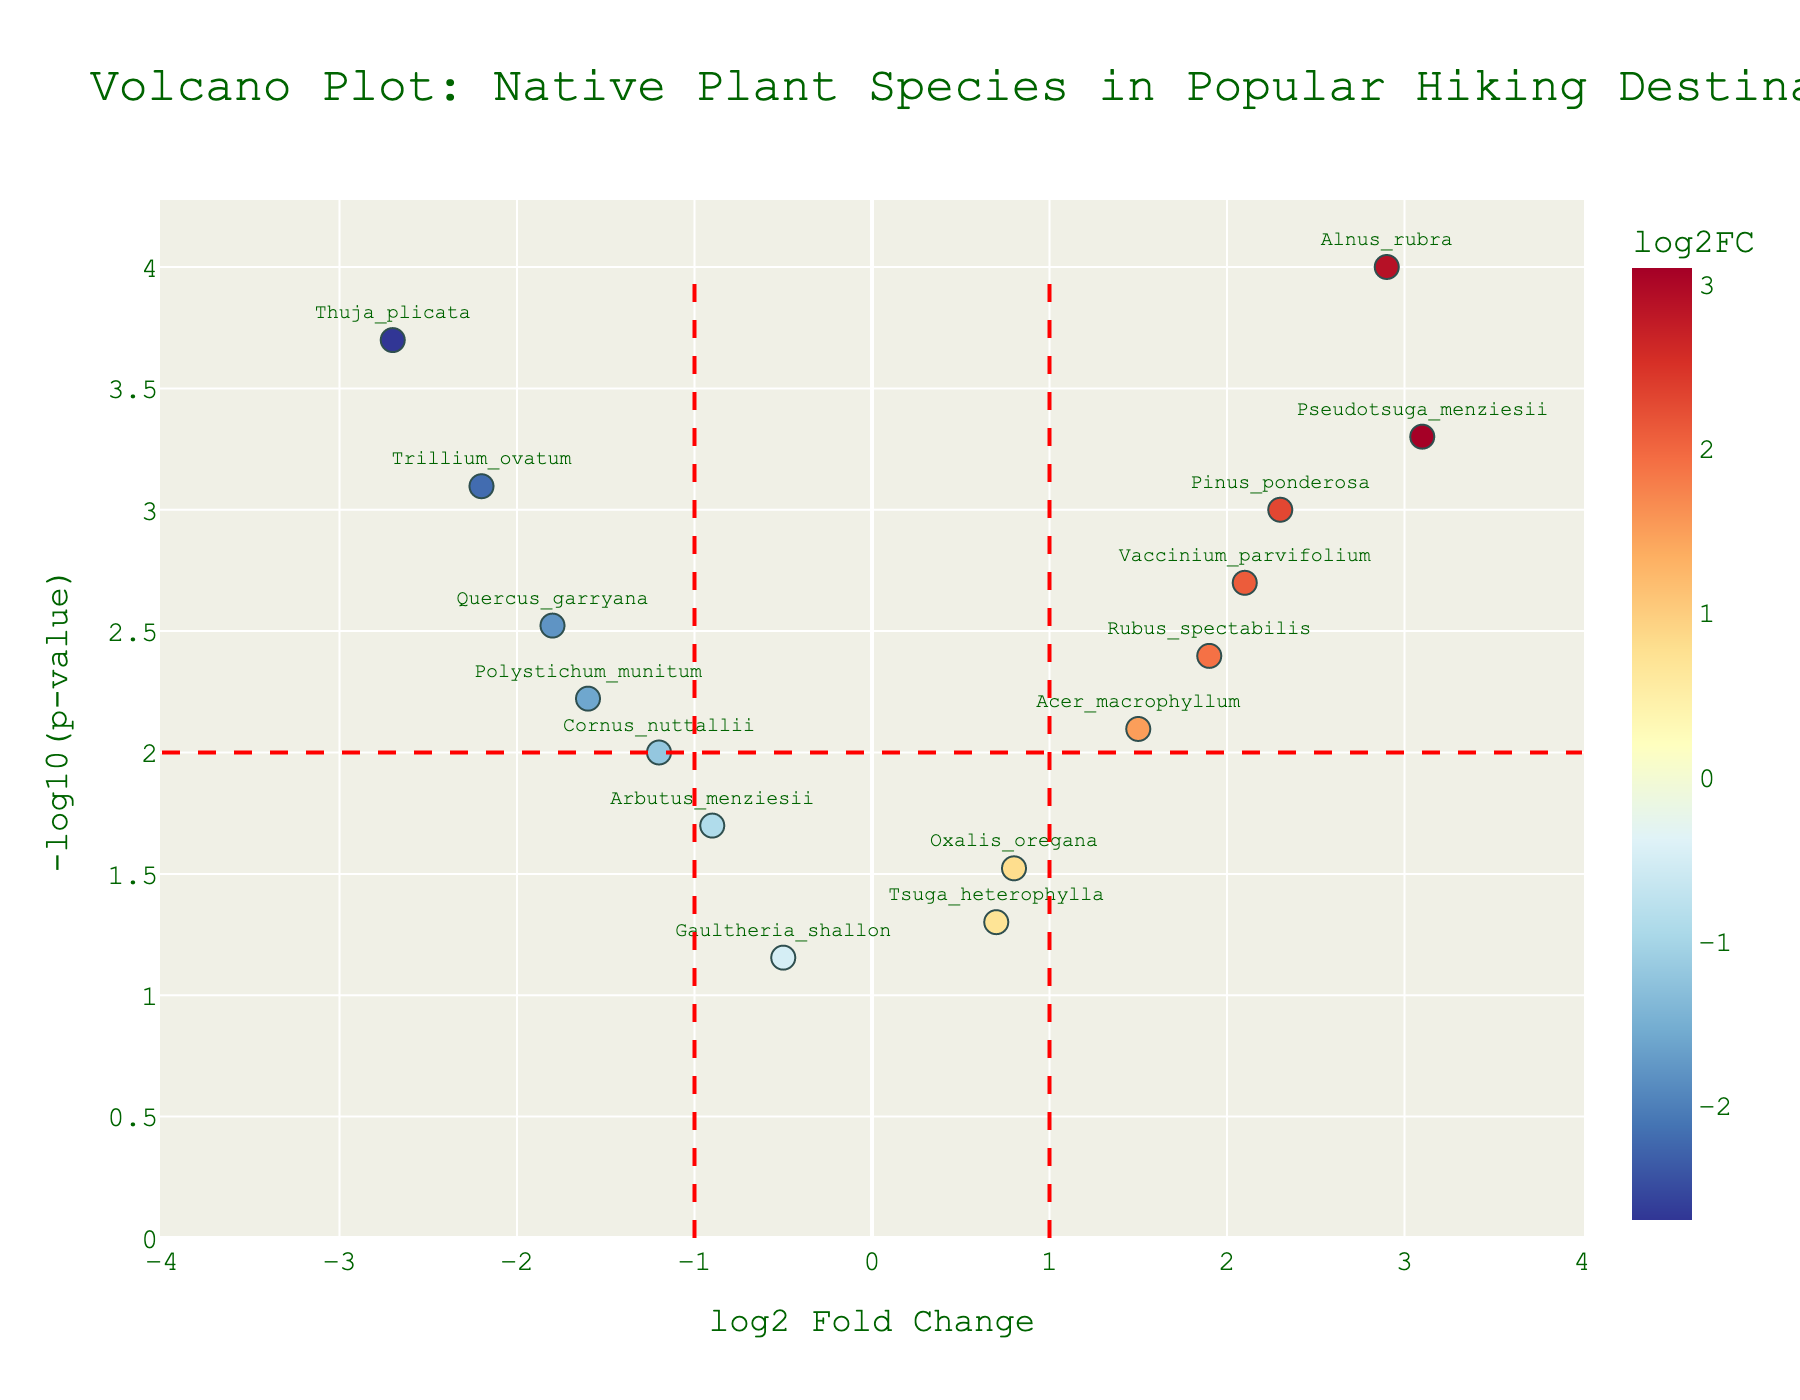what is the title of the plot? The title is usually displayed at the top of the plot and serves to describe what the plot is about. In this case, it indicates the type of plot and the context of the data. The title of the plot is "Volcano Plot: Native Plant Species in Popular Hiking Destinations".
Answer: Volcano Plot: Native Plant Species in Popular Hiking Destinations How many genes have a log2FoldChange greater than 2? To find the number of genes with a log2FoldChange greater than 2, look at the x-axis and count the number of data points to the right of the vertical line at log2FoldChange=2. From the data points visible on the plot, we can see multiple points beyond this threshold.
Answer: 5 Which gene has the most significant p-value? The significance of the p-value is represented by the y-axis on the plot (higher values of -log10(p-value)). To find the gene with the most significant p-value, look for the data point with the highest y-axis value. According to the dataset, Alnus rubra has the highest -log10(p-value).
Answer: Alnus_rubra What is the log2FoldChange of Trillium ovatum? To find the log2FoldChange, look for the horizontal position of the data point labeled "Trillium ovatum". The x-axis denotes log2FoldChange values. From the plot data, Trillium ovatum has a log2FoldChange of -2.2.
Answer: -2.2 Compare the log2FoldChange of Quercus garryana and Vaccinium parvifolium. Which one is higher? To compare the log2FoldChange, look at the x-axis positions of Quercus garryana and Vaccinium parvifolium. Quercus garryana has a log2FoldChange of -1.8 and Vaccinium parvifolium has a log2FoldChange of 2.1. Since 2.1 is greater than -1.8, Vaccinium parvifolium has the higher value.
Answer: Vaccinium parvifolium Which gene has the lowest log2FoldChange? To determine the gene with the lowest log2FoldChange, look at the data point that is furthest to the left on the x-axis. According to the data and the plot, Thuja plicata has the lowest log2FoldChange at -2.7.
Answer: Thuja_plicata How many genes fall below the p-value threshold of 0.01 (corresponding to -log10(p-value) > 2)? The p-value threshold is represented by the horizontal line at -log10(p-value) = 2. Count the number of data points above this line to determine how many genes have p-values less than 0.01.
Answer: 8 Which gene exhibits the highest positive log2FoldChange and how significant is its p-value? To find this, look for the data point furthest to the right on the x-axis and then check its y-value for significance. Pseudotsuga menziesii has the highest positive log2FoldChange of 3.1 and a corresponding -log10(p-value) of approximately 3.3.
Answer: Pseudotsuga_menziesii, 3.3 List all genes with a log2FoldChange between -1 and 1. Examine the x-axis range between -1 and 1 and identify the genes within this range: Gaultheria shallon, Tsuga heterophylla, and Oxalis oregana fit within this range.
Answer: Gaultheria_shallon, Tsuga_heterophylla, Oxalis_oregana 